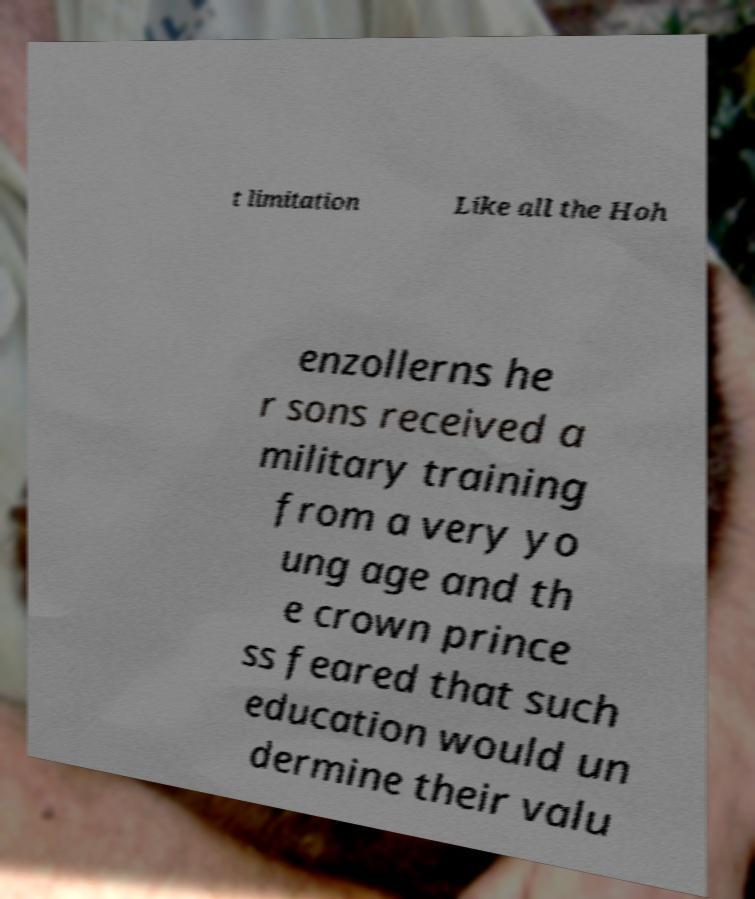Can you accurately transcribe the text from the provided image for me? t limitation Like all the Hoh enzollerns he r sons received a military training from a very yo ung age and th e crown prince ss feared that such education would un dermine their valu 